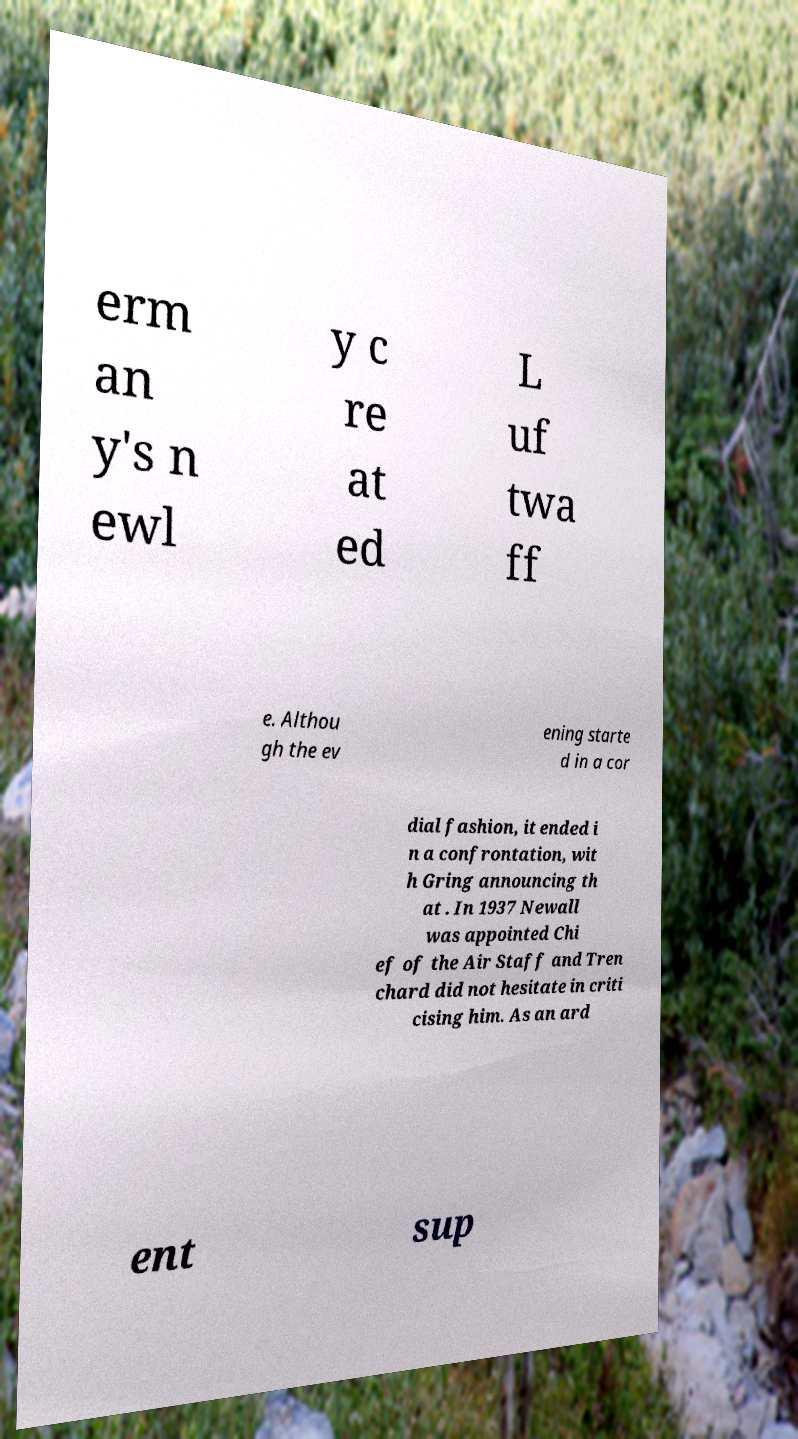Could you assist in decoding the text presented in this image and type it out clearly? erm an y's n ewl y c re at ed L uf twa ff e. Althou gh the ev ening starte d in a cor dial fashion, it ended i n a confrontation, wit h Gring announcing th at . In 1937 Newall was appointed Chi ef of the Air Staff and Tren chard did not hesitate in criti cising him. As an ard ent sup 